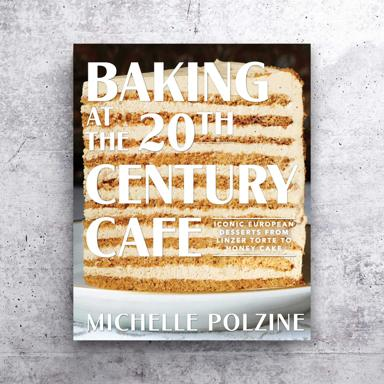What kind of dishes or recipes can we expect from this book? From "Baking at the 20th Century Cafe," you can expect a delightful range of iconic European desserts. The book offers recipes for exquisite cakes, flaky pastries, and decadent sweet treats that characterize the charm of 20th-century European cafes. It’s a culinary journey that revisits and revives classic desserts with a modern twist. 